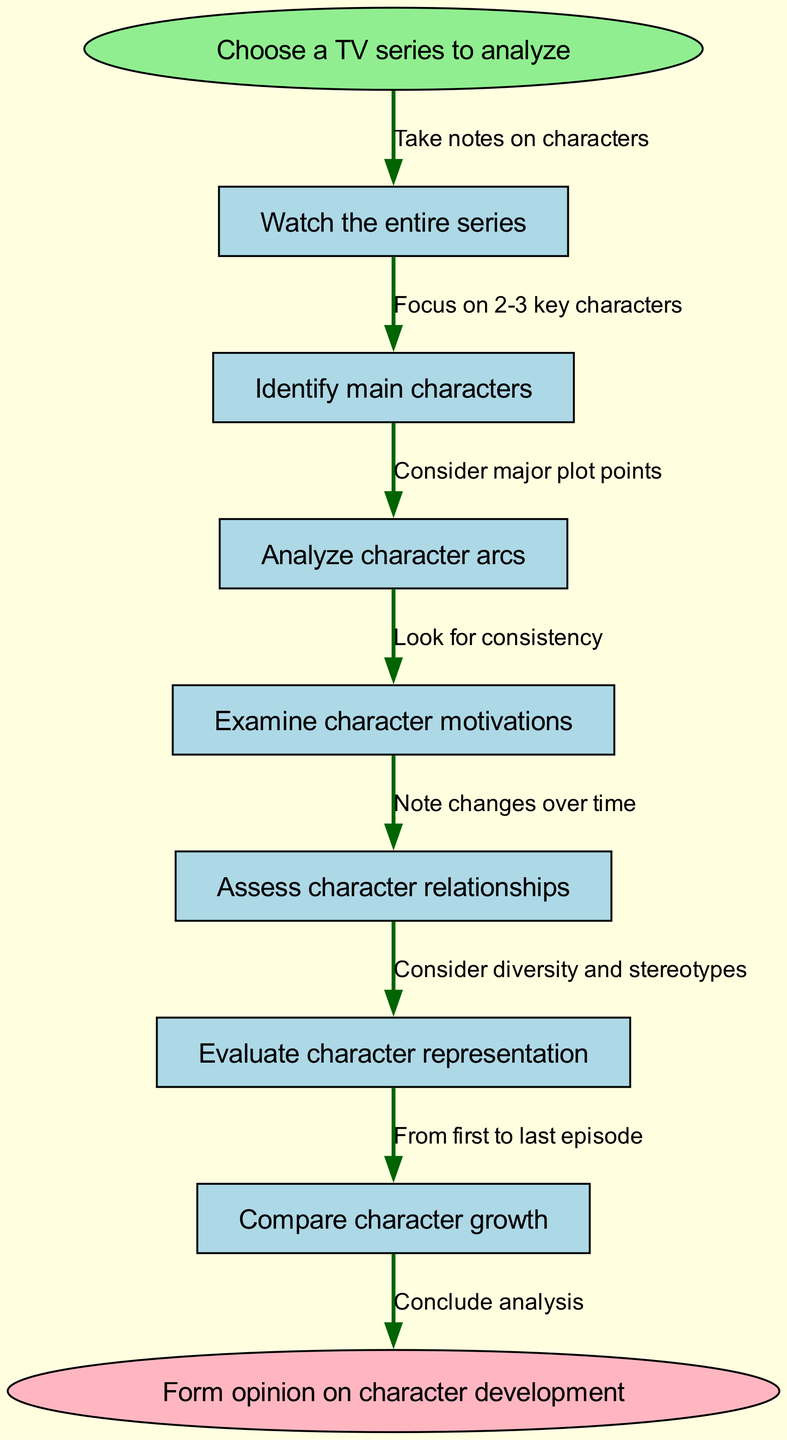What is the starting point of the flowchart? The flowchart begins with the instruction to "Choose a TV series to analyze," which is represented as the starting node.
Answer: Choose a TV series to analyze How many steps are there in the analysis? The diagram lists six steps in total that outline the character development analysis, as seen in the steps section.
Answer: 6 What is the second step in the flowchart? The second step displayed in the flowchart is "Identify main characters," which follows the opening instruction.
Answer: Identify main characters What do you do after assessing character relationships? The next step after "Assess character relationships" is to "Evaluate character representation," which illustrates the flow of the analysis.
Answer: Evaluate character representation What is considered when analyzing character arcs? The instruction specifies to "Consider major plot points" when analyzing character arcs, linking the character analysis to the overall series narrative.
Answer: Consider major plot points What is the end of the flowchart? The flowchart concludes with the instruction to "Form opinion on character development," indicating the final outcome of the analysis process.
Answer: Form opinion on character development At which step do you note changes over time? Changes over time are noted during the "Assess character relationships" step, emphasizing the dynamic nature of character interactions.
Answer: Assess character relationships How many nodes are in this flowchart? The flowchart includes eight nodes: one start, six step nodes, and one end node, illustrating the overall structure of the analysis process.
Answer: 8 What edge leads from the first step to the second? The edge connecting the first step "Watch the entire series" to the second step "Identify main characters" indicates the action of focusing on characters after viewing the series.
Answer: Take notes on characters 